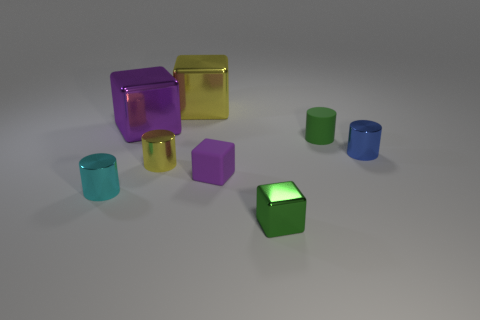How many other things are there of the same material as the tiny blue thing?
Offer a terse response. 5. What number of objects are tiny metallic cylinders that are left of the tiny green cylinder or small matte blocks?
Offer a terse response. 3. There is a purple thing to the left of the small cube behind the cyan object; what is its shape?
Ensure brevity in your answer.  Cube. There is a small green object behind the small cyan cylinder; is it the same shape as the tiny blue object?
Make the answer very short. Yes. There is a metal cube that is in front of the tiny rubber cube; what is its color?
Your response must be concise. Green. How many balls are tiny shiny things or purple metal things?
Your answer should be compact. 0. What is the size of the yellow thing in front of the large metal thing that is in front of the big yellow cube?
Give a very brief answer. Small. There is a small matte block; is its color the same as the metallic cylinder right of the small green shiny cube?
Give a very brief answer. No. There is a small purple matte block; what number of cyan cylinders are on the right side of it?
Give a very brief answer. 0. Are there fewer green shiny objects than tiny cyan cubes?
Make the answer very short. No. 